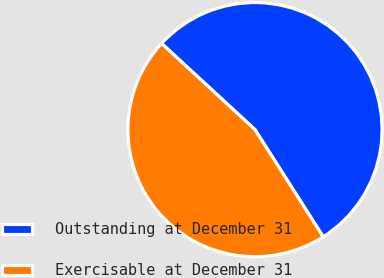Convert chart to OTSL. <chart><loc_0><loc_0><loc_500><loc_500><pie_chart><fcel>Outstanding at December 31<fcel>Exercisable at December 31<nl><fcel>54.12%<fcel>45.88%<nl></chart> 